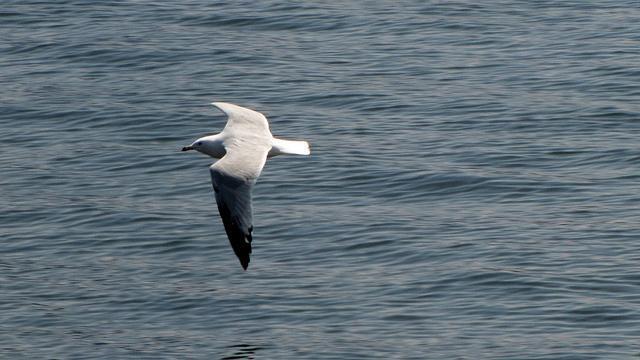How many birds are there?
Give a very brief answer. 1. How many different types of bird are in the image?
Give a very brief answer. 1. How many colors does the bird have?
Give a very brief answer. 2. How many birds are shown?
Give a very brief answer. 1. How many birds are flying?
Give a very brief answer. 1. How many white birds are flying?
Give a very brief answer. 1. 